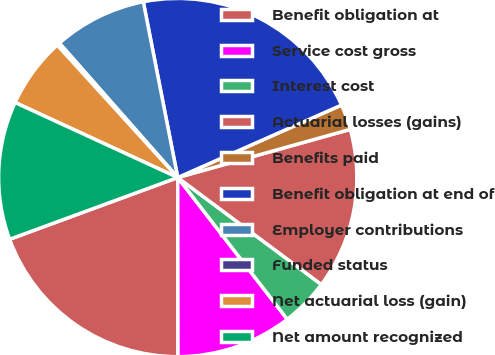<chart> <loc_0><loc_0><loc_500><loc_500><pie_chart><fcel>Benefit obligation at<fcel>Service cost gross<fcel>Interest cost<fcel>Actuarial losses (gains)<fcel>Benefits paid<fcel>Benefit obligation at end of<fcel>Employer contributions<fcel>Funded status<fcel>Net actuarial loss (gain)<fcel>Net amount recognized<nl><fcel>19.42%<fcel>10.45%<fcel>4.34%<fcel>14.52%<fcel>2.3%<fcel>21.45%<fcel>8.41%<fcel>0.26%<fcel>6.37%<fcel>12.48%<nl></chart> 